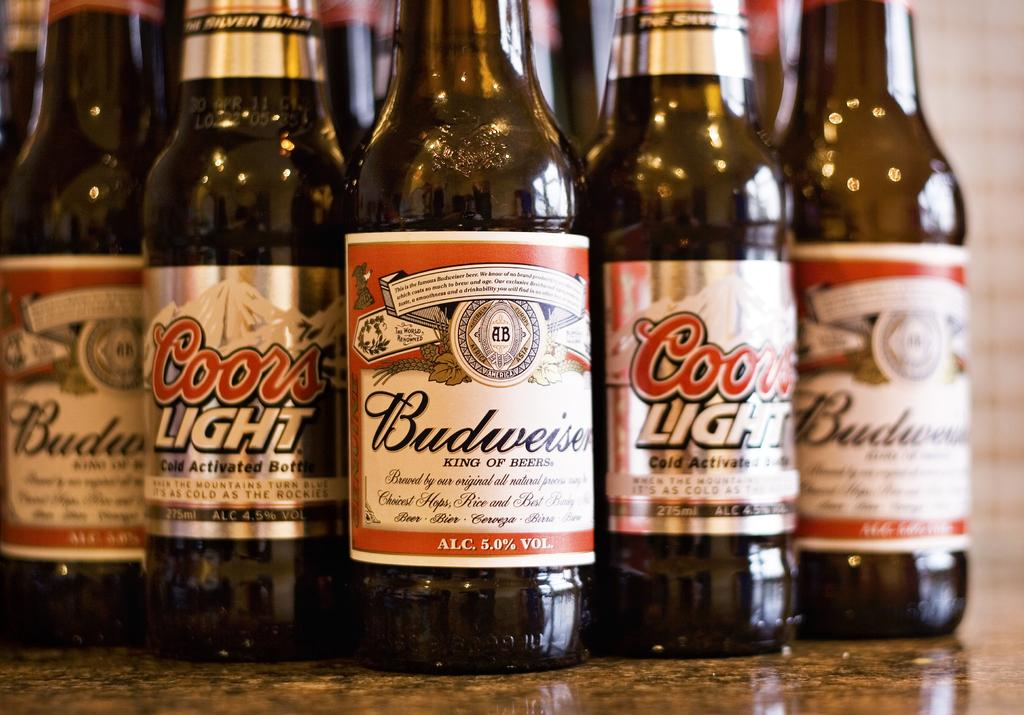<image>
Describe the image concisely. 5 bottles of beer next to each other with three of them being Budwiser and two are Coors light. 